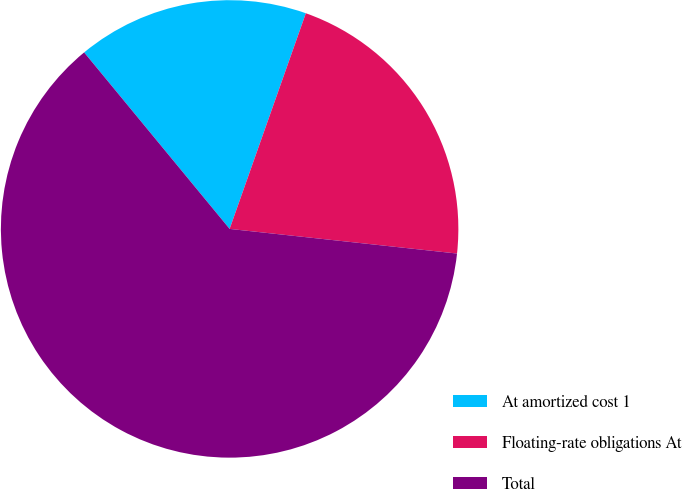Convert chart to OTSL. <chart><loc_0><loc_0><loc_500><loc_500><pie_chart><fcel>At amortized cost 1<fcel>Floating-rate obligations At<fcel>Total<nl><fcel>16.38%<fcel>21.31%<fcel>62.31%<nl></chart> 